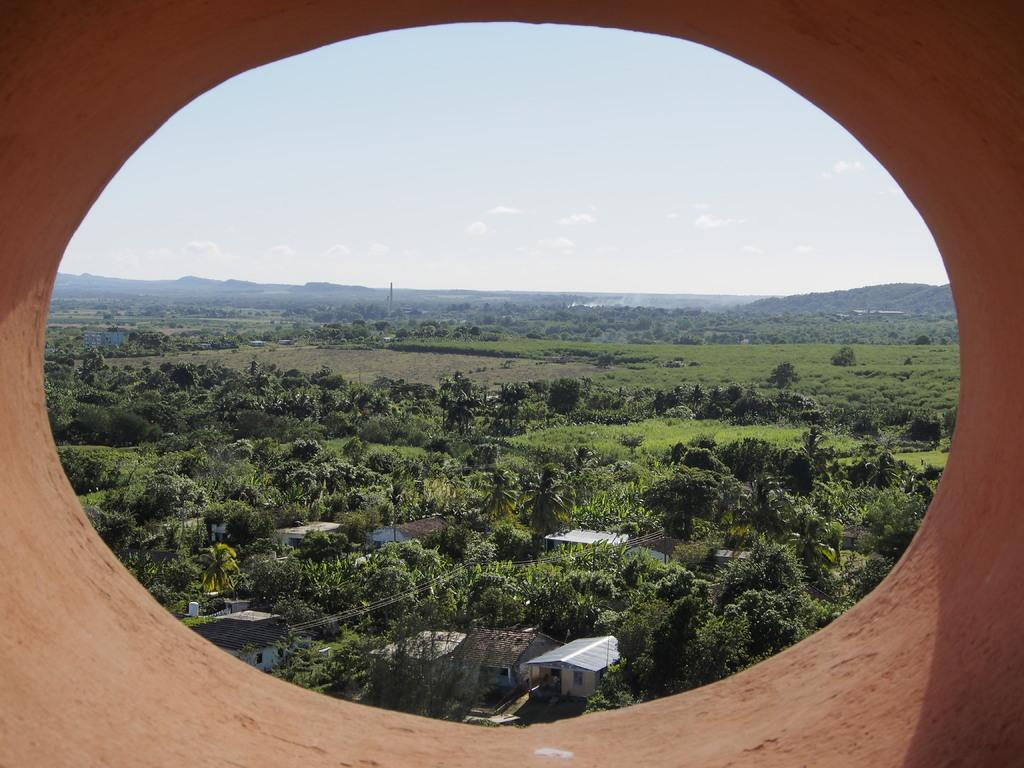What types of structures are located at the bottom of the image? There are houses at the bottom of the image. What other objects can be seen at the bottom of the image? There are trees at the bottom of the image. What is visible at the top of the image? The sky is visible at the top of the image. Can you tell me how many doctors are present in the image? There are no doctors present in the image. What type of development can be seen in the image? The image does not show any development; it features houses and trees at the bottom and the sky at the top. 